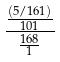Convert formula to latex. <formula><loc_0><loc_0><loc_500><loc_500>\frac { \frac { ( 5 / 1 6 1 ) } { 1 0 1 } } { \frac { 1 6 8 } { 1 } }</formula> 